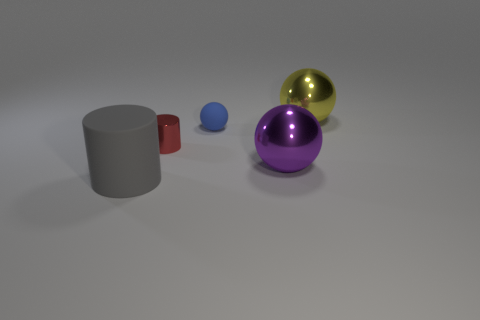Subtract all large yellow metal balls. How many balls are left? 2 Add 4 cyan balls. How many objects exist? 9 Subtract all cylinders. How many objects are left? 3 Subtract 0 gray blocks. How many objects are left? 5 Subtract all purple balls. Subtract all yellow cylinders. How many balls are left? 2 Subtract all purple rubber blocks. Subtract all red metal cylinders. How many objects are left? 4 Add 2 yellow balls. How many yellow balls are left? 3 Add 2 cylinders. How many cylinders exist? 4 